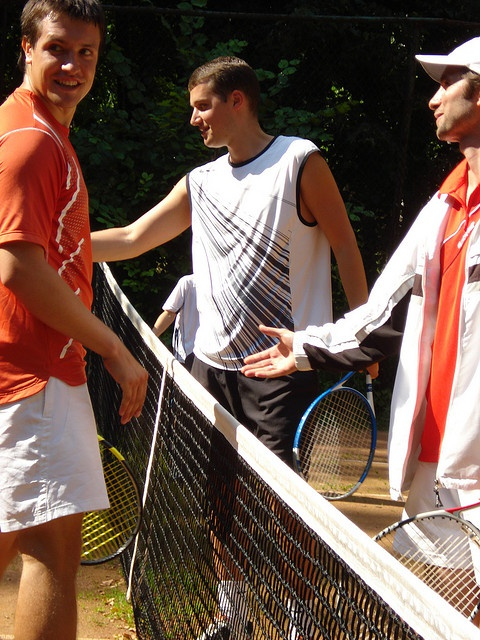Describe the objects in this image and their specific colors. I can see people in black, maroon, gray, and tan tones, people in black, white, maroon, and gray tones, people in black, white, darkgray, lightpink, and gray tones, tennis racket in black, darkgray, ivory, and olive tones, and tennis racket in black, maroon, gray, and tan tones in this image. 